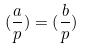<formula> <loc_0><loc_0><loc_500><loc_500>( \frac { a } { p } ) = ( \frac { b } { p } )</formula> 